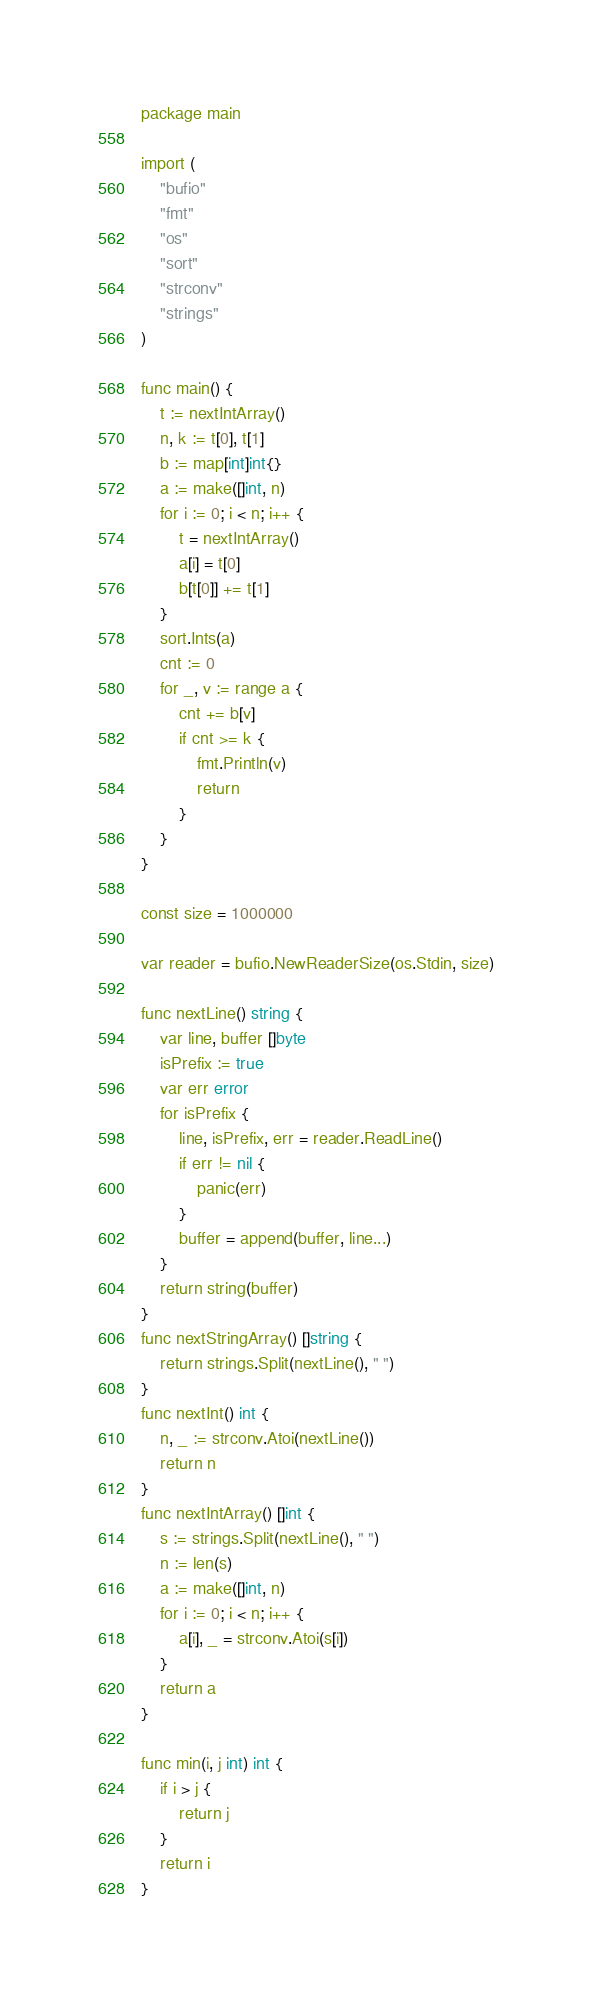Convert code to text. <code><loc_0><loc_0><loc_500><loc_500><_Go_>package main

import (
	"bufio"
	"fmt"
	"os"
	"sort"
	"strconv"
	"strings"
)

func main() {
	t := nextIntArray()
	n, k := t[0], t[1]
	b := map[int]int{}
	a := make([]int, n)
	for i := 0; i < n; i++ {
		t = nextIntArray()
		a[i] = t[0]
		b[t[0]] += t[1]
	}
	sort.Ints(a)
	cnt := 0
	for _, v := range a {
		cnt += b[v]
		if cnt >= k {
			fmt.Println(v)
			return
		}
	}
}

const size = 1000000

var reader = bufio.NewReaderSize(os.Stdin, size)

func nextLine() string {
	var line, buffer []byte
	isPrefix := true
	var err error
	for isPrefix {
		line, isPrefix, err = reader.ReadLine()
		if err != nil {
			panic(err)
		}
		buffer = append(buffer, line...)
	}
	return string(buffer)
}
func nextStringArray() []string {
	return strings.Split(nextLine(), " ")
}
func nextInt() int {
	n, _ := strconv.Atoi(nextLine())
	return n
}
func nextIntArray() []int {
	s := strings.Split(nextLine(), " ")
	n := len(s)
	a := make([]int, n)
	for i := 0; i < n; i++ {
		a[i], _ = strconv.Atoi(s[i])
	}
	return a
}

func min(i, j int) int {
	if i > j {
		return j
	}
	return i
}
</code> 